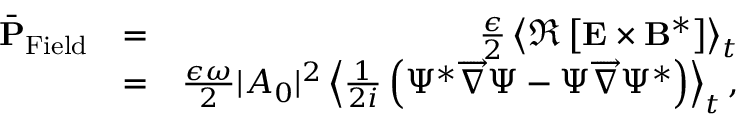Convert formula to latex. <formula><loc_0><loc_0><loc_500><loc_500>\begin{array} { r l r } { \bar { P } _ { F i e l d } } & { = } & { \frac { \epsilon } { 2 } \left \langle \Re \left [ { E } \times { B } ^ { * } \right ] \right \rangle _ { t } } \\ & { = } & { \frac { \epsilon \omega } { 2 } | A _ { 0 } | ^ { 2 } \left \langle \frac { 1 } { 2 i } \left ( \Psi ^ { * } \overrightarrow { \nabla } \Psi - \Psi \overrightarrow { \nabla } \Psi ^ { * } \right ) \right \rangle _ { t } , } \end{array}</formula> 